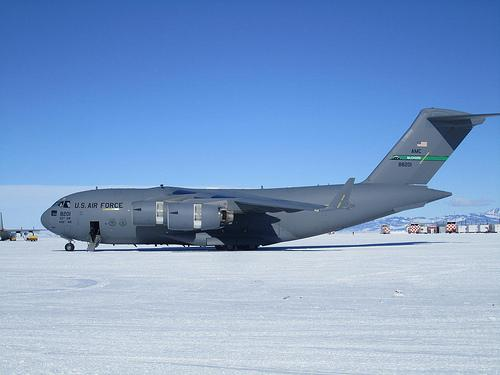Question: why is this airplane on the ground?
Choices:
A. To takeoff.
B. To let people in/out.
C. To gas up.
D. To land.
Answer with the letter. Answer: B Question: where is the american flag located?
Choices:
A. On a pole.
B. On my roof.
C. On the tail.
D. On the car.
Answer with the letter. Answer: C Question: who would fly this vehicle?
Choices:
A. A marine.
B. A pilot.
C. A copilot.
D. A soldier in the Air Force.
Answer with the letter. Answer: B Question: what branch of military is this airplane from?
Choices:
A. Army.
B. Marines.
C. U.S. Air Force.
D. Navy.
Answer with the letter. Answer: C 